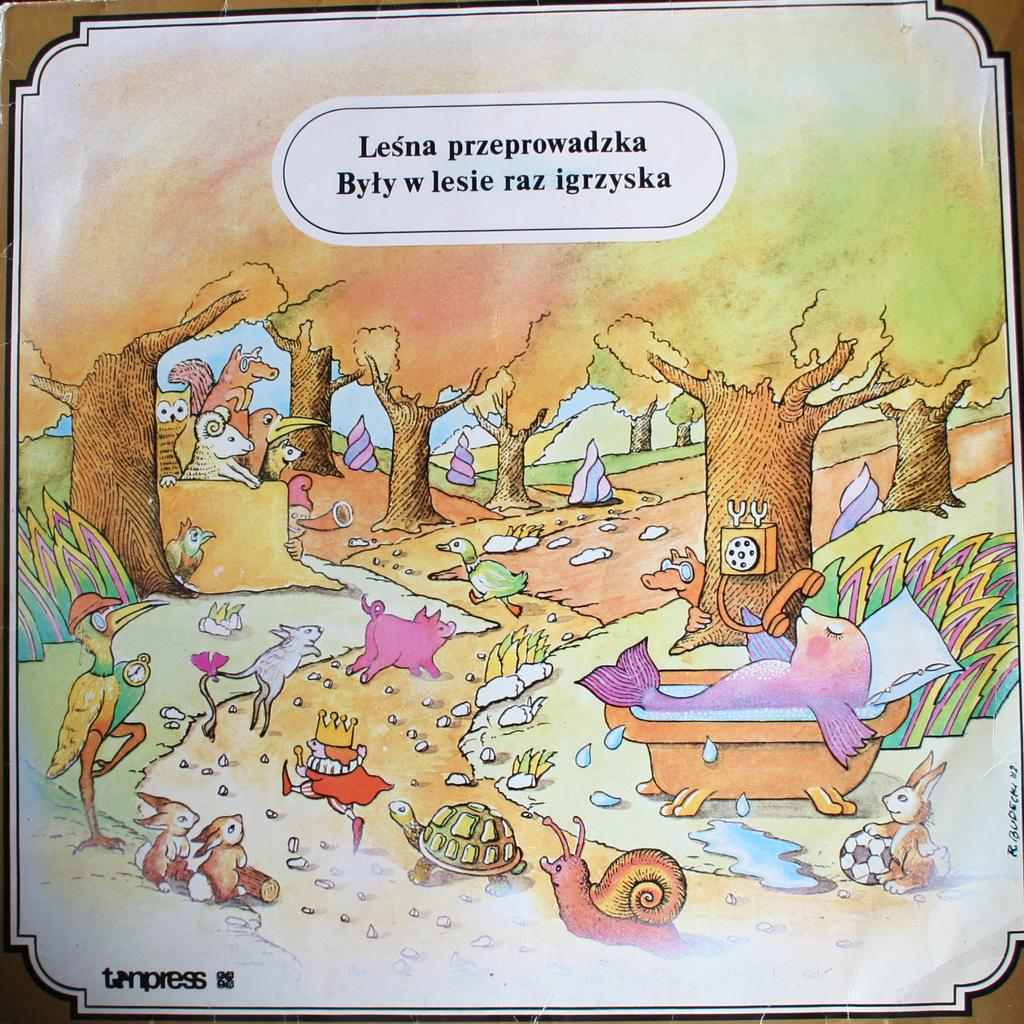What is featured on the poster in the image? The poster has a picture of animals and trees. What else can be seen on the poster besides the image? There is some matter written at the top of the poster. What type of sail can be seen on the poster? There is no sail present on the poster; it features a picture of animals and trees, along with some written matter at the top. Is there a board depicted on the poster? No, there is no board depicted on the poster. 